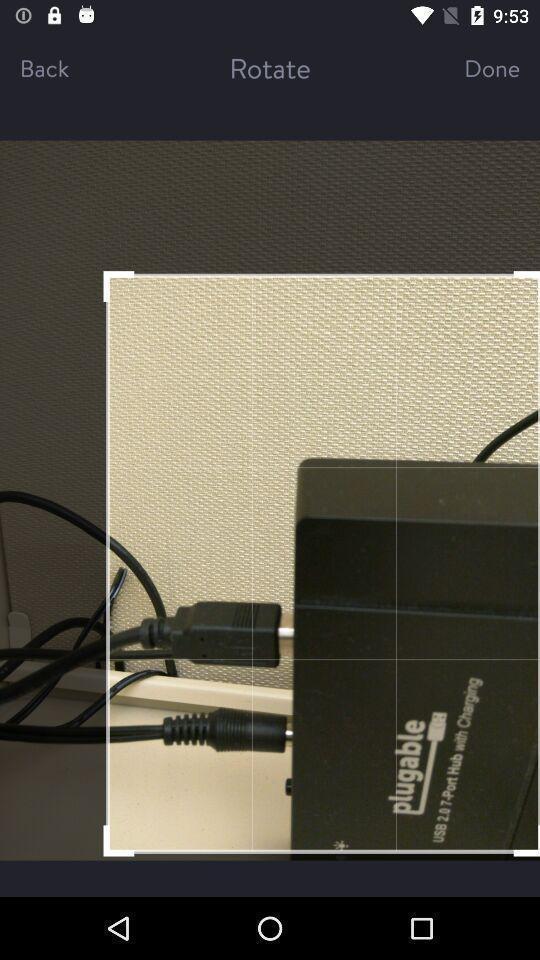Describe the visual elements of this screenshot. Page that displaying an image. 